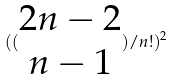Convert formula to latex. <formula><loc_0><loc_0><loc_500><loc_500>( ( \begin{matrix} 2 n - 2 \\ n - 1 \end{matrix} ) / n ! ) ^ { 2 }</formula> 